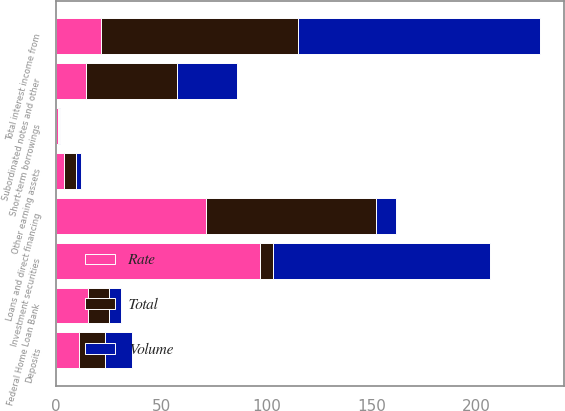Convert chart to OTSL. <chart><loc_0><loc_0><loc_500><loc_500><stacked_bar_chart><ecel><fcel>Loans and direct financing<fcel>Investment securities<fcel>Other earning assets<fcel>Total interest income from<fcel>Deposits<fcel>Short-term borrowings<fcel>Federal Home Loan Bank<fcel>Subordinated notes and other<nl><fcel>Rate<fcel>71.3<fcel>96.8<fcel>3.8<fcel>21.7<fcel>10.9<fcel>1.1<fcel>15.4<fcel>14.3<nl><fcel>Volume<fcel>9.6<fcel>103.2<fcel>2.2<fcel>115<fcel>12.6<fcel>0.5<fcel>5.6<fcel>28.8<nl><fcel>Total<fcel>80.9<fcel>6.4<fcel>6<fcel>93.3<fcel>12.6<fcel>0.6<fcel>9.8<fcel>43.1<nl></chart> 